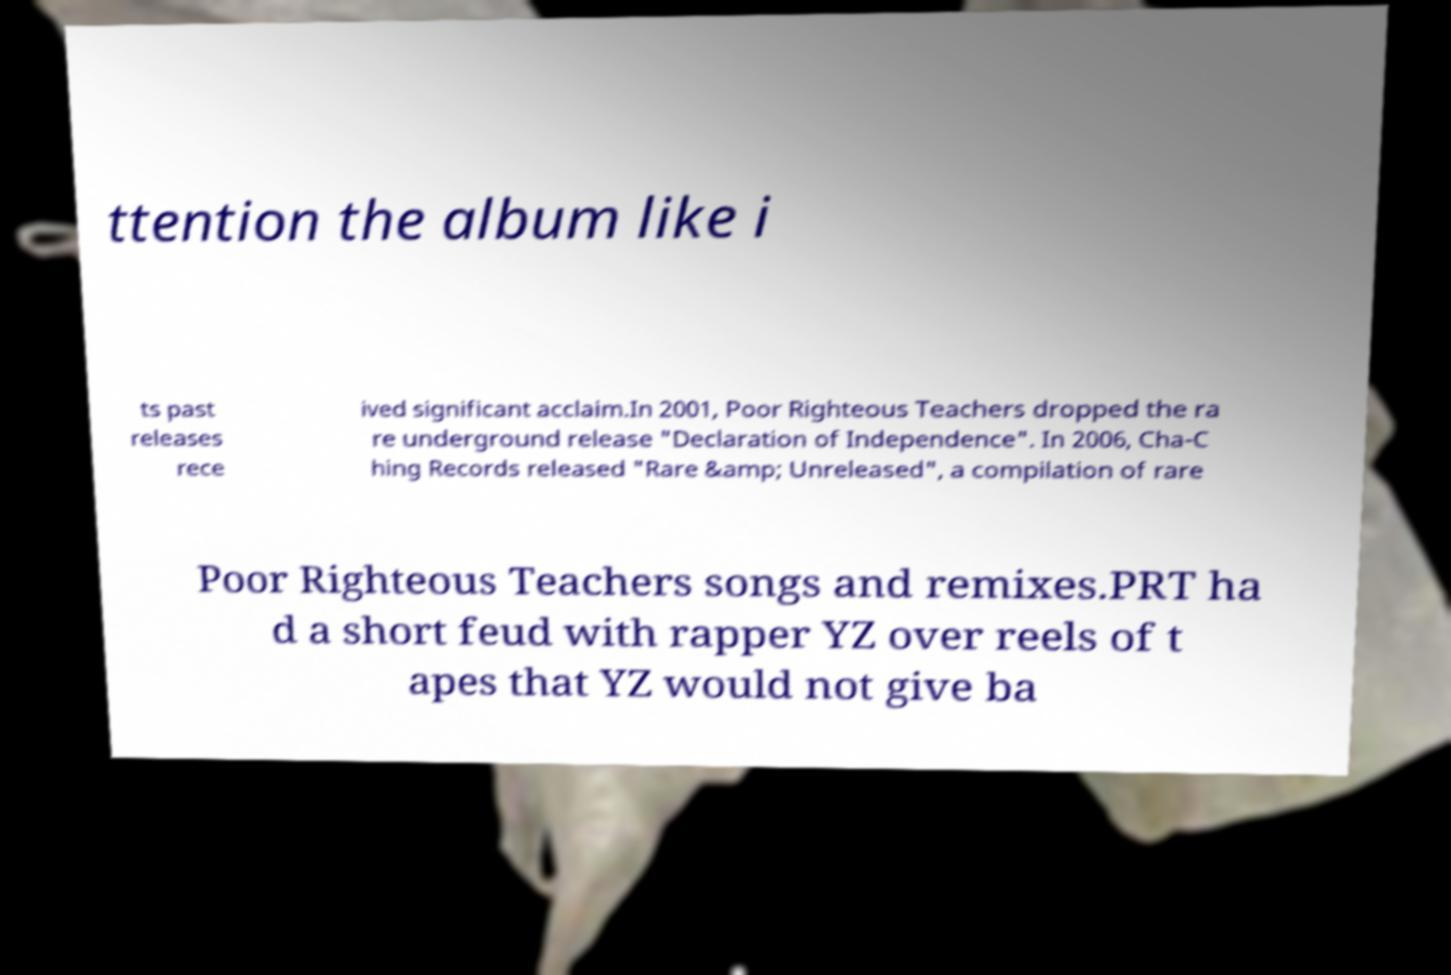Please identify and transcribe the text found in this image. ttention the album like i ts past releases rece ived significant acclaim.In 2001, Poor Righteous Teachers dropped the ra re underground release "Declaration of Independence". In 2006, Cha-C hing Records released "Rare &amp; Unreleased", a compilation of rare Poor Righteous Teachers songs and remixes.PRT ha d a short feud with rapper YZ over reels of t apes that YZ would not give ba 